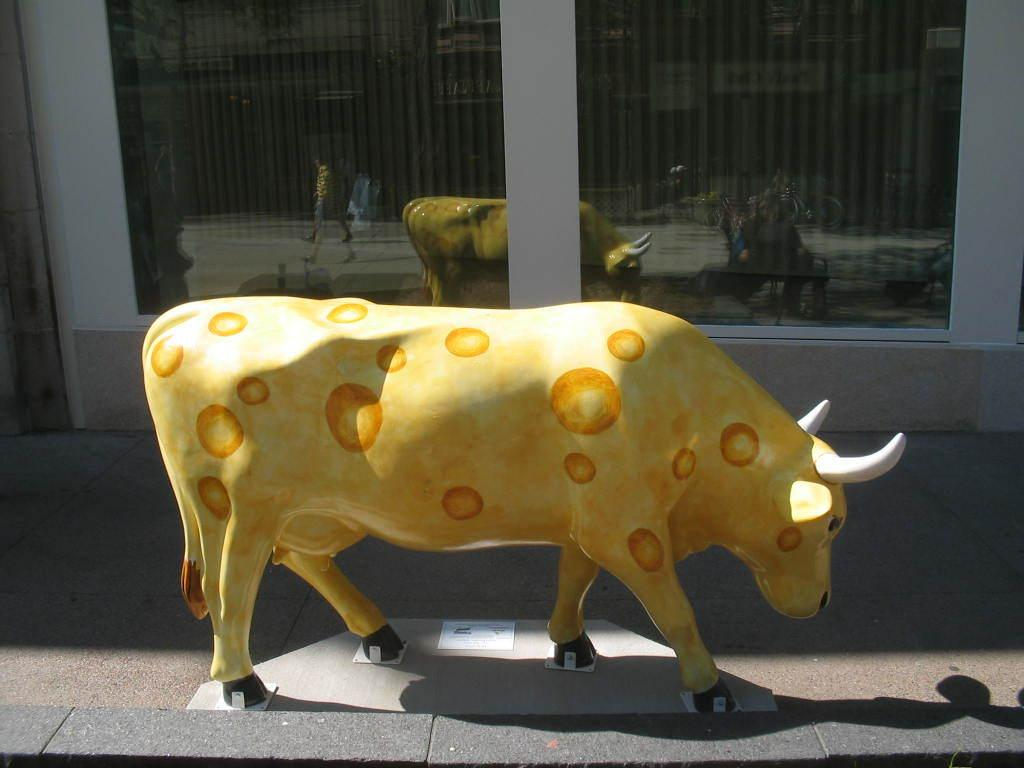What is depicted at the bottom of the image? There is a statue of an animal at the bottom of the image. What objects can be seen in the background of the image? There are glasses in the background of the image. What do the glasses reflect in the image? The glasses reflect a statue, a building, and a person. Can you find the receipt for the giraffe purchase in the image? There is no giraffe or receipt present in the image. 